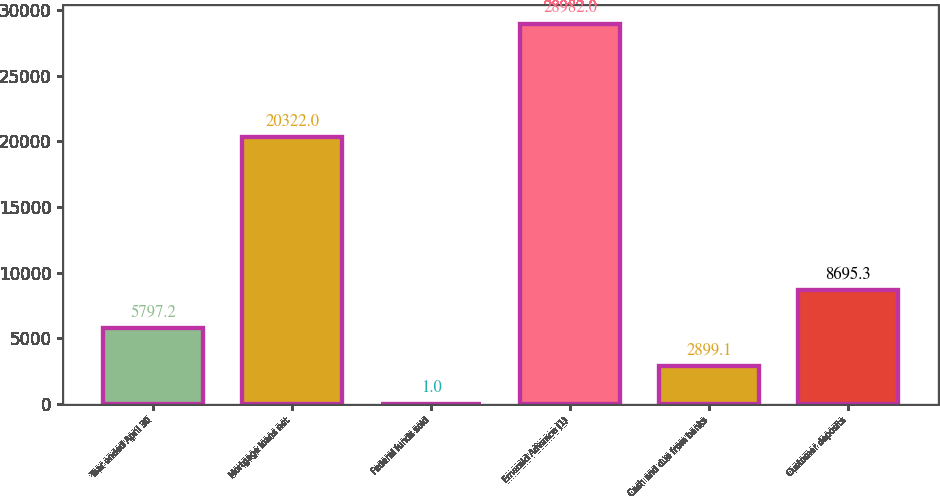Convert chart to OTSL. <chart><loc_0><loc_0><loc_500><loc_500><bar_chart><fcel>Year ended April 30<fcel>Mortgage loans net<fcel>Federal funds sold<fcel>Emerald Advance (1)<fcel>Cash and due from banks<fcel>Customer deposits<nl><fcel>5797.2<fcel>20322<fcel>1<fcel>28982<fcel>2899.1<fcel>8695.3<nl></chart> 